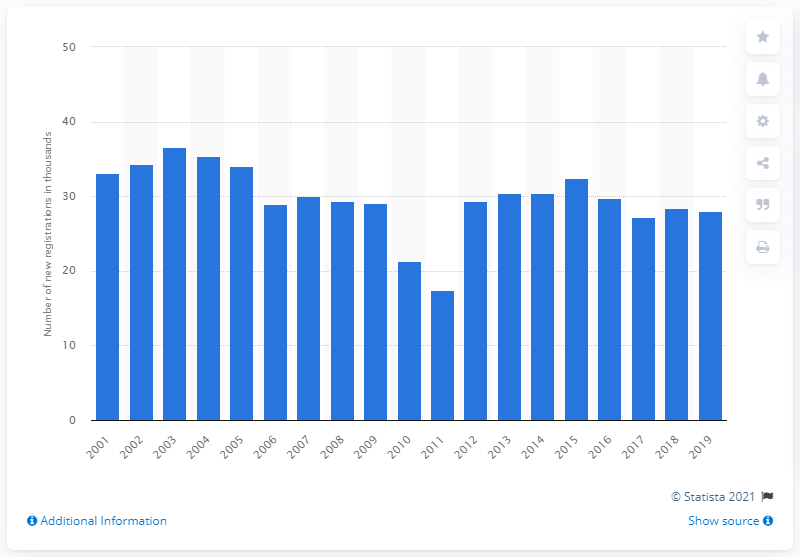Point out several critical features in this image. In 2003, a peak in the sales of the Toyota Yaris was observed. 